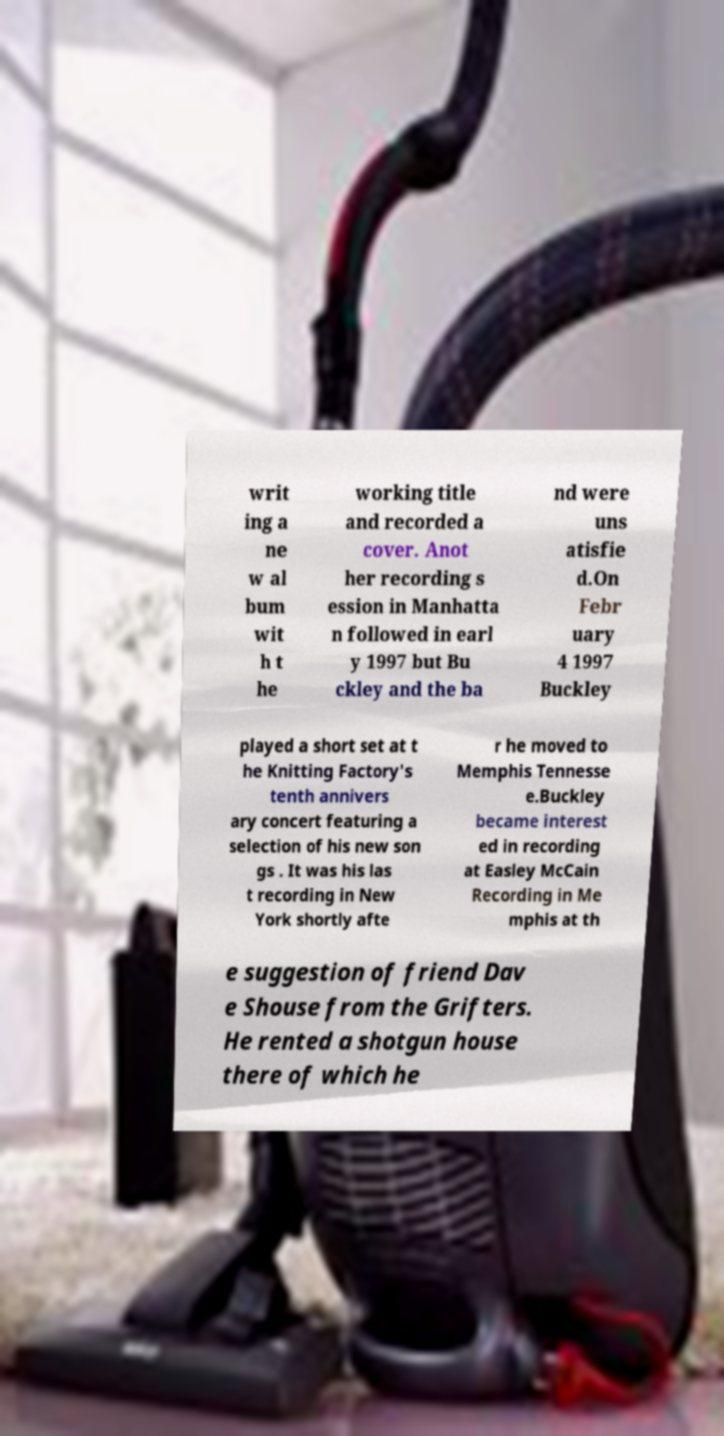Please identify and transcribe the text found in this image. writ ing a ne w al bum wit h t he working title and recorded a cover. Anot her recording s ession in Manhatta n followed in earl y 1997 but Bu ckley and the ba nd were uns atisfie d.On Febr uary 4 1997 Buckley played a short set at t he Knitting Factory's tenth annivers ary concert featuring a selection of his new son gs . It was his las t recording in New York shortly afte r he moved to Memphis Tennesse e.Buckley became interest ed in recording at Easley McCain Recording in Me mphis at th e suggestion of friend Dav e Shouse from the Grifters. He rented a shotgun house there of which he 